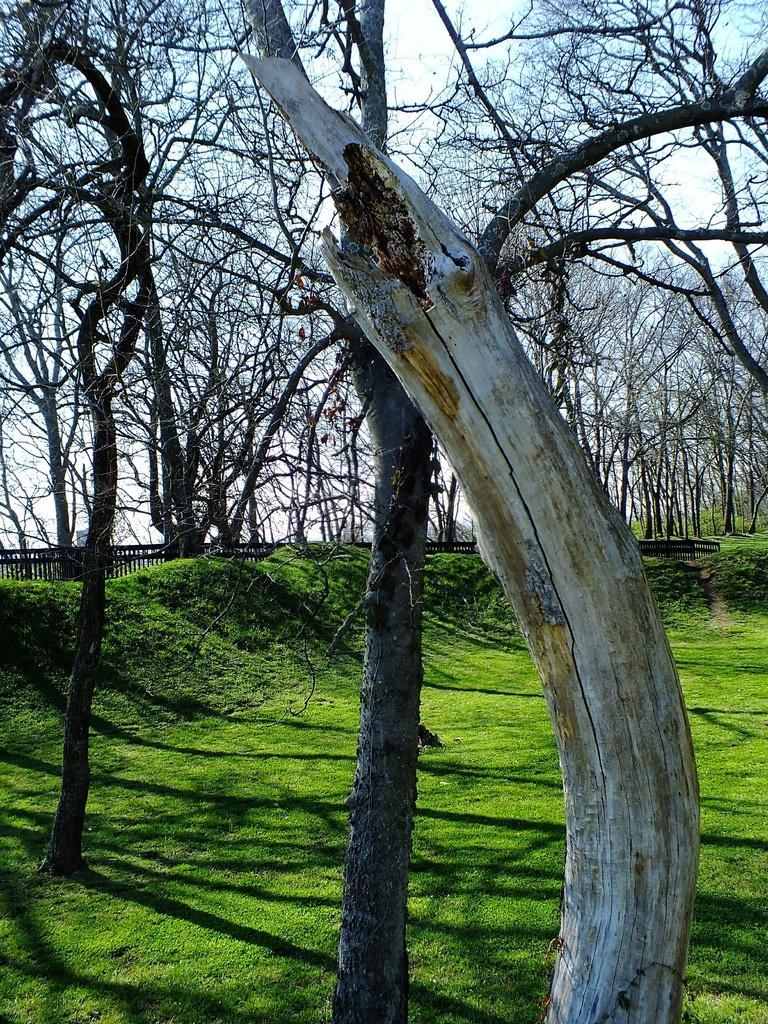How would you summarize this image in a sentence or two? In the image we can see the ground is covered with grass and there is a dry tree trunk. There are dry trees and behind there is an iron fencing. 